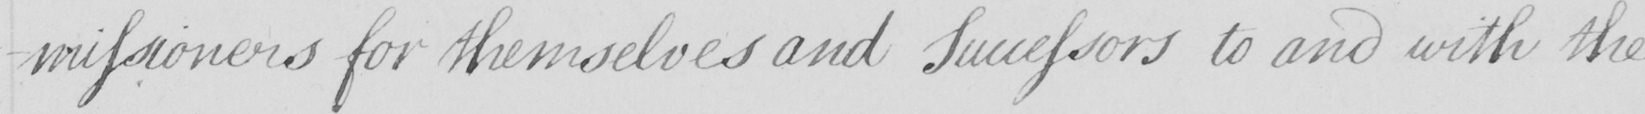Please transcribe the handwritten text in this image. - missioners for themselves and Successors to and with the 